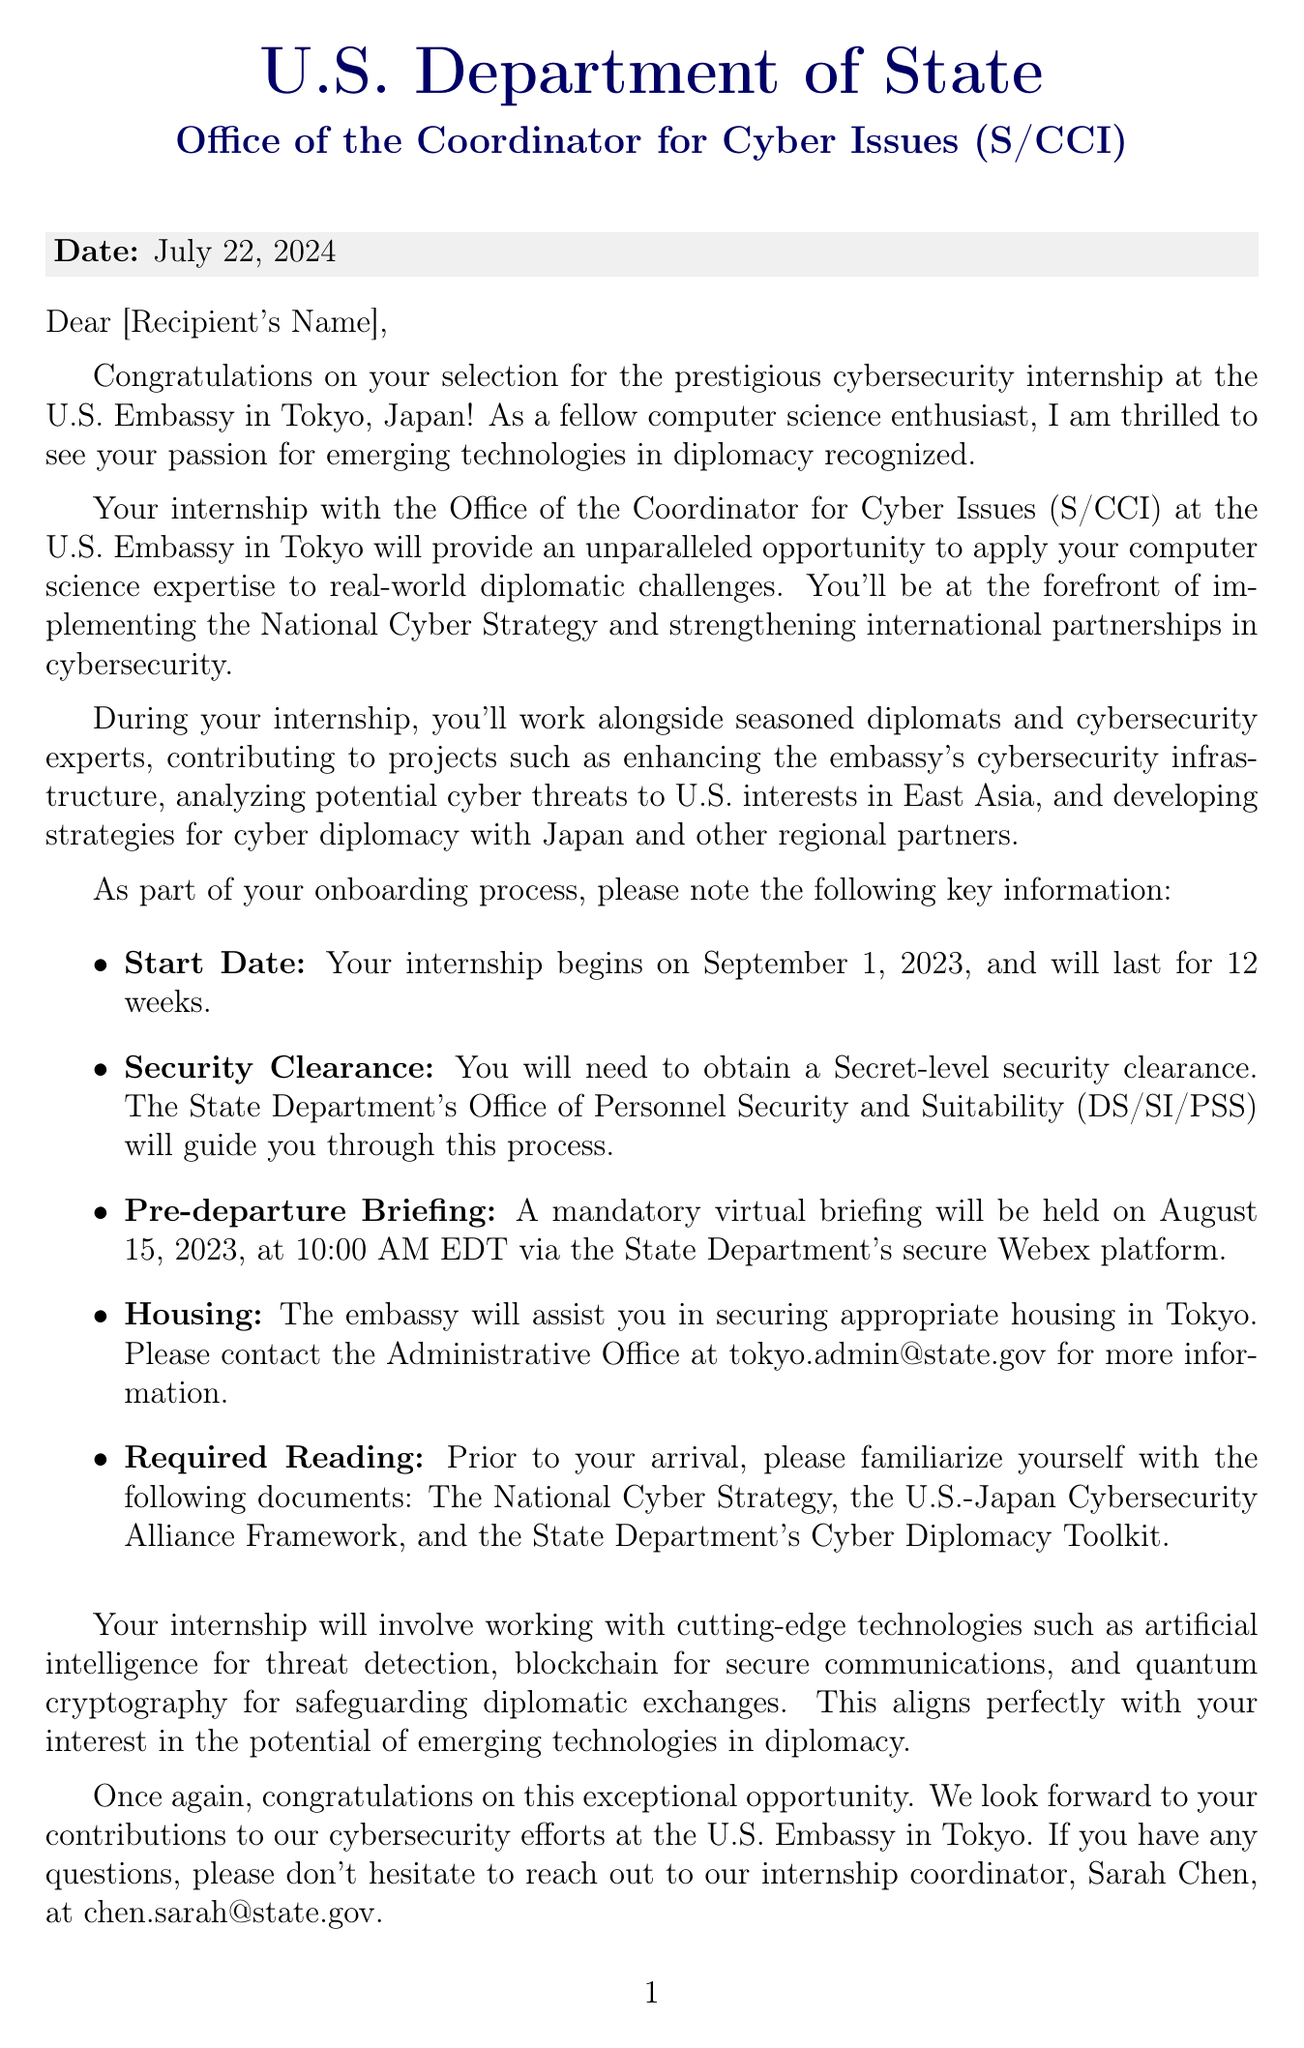What is the recipient's internship duration? The internship duration is specified in the letter as lasting for 12 weeks, starting from the start date.
Answer: 12 weeks When is the mandatory pre-departure briefing scheduled? The document provides a specific date and time for the briefing in the onboarding section.
Answer: August 15, 2023, at 10:00 AM EDT What is the title of the position of John Smith? The letter states John Smith's position in the closing section.
Answer: Director, Office of the Coordinator for Cyber Issues (S/CCI) Where should the recipient contact for housing assistance? The document lists the email contact for housing information in the onboarding section.
Answer: tokyo.admin@state.gov What is the start date of the internship? The start date is explicitly mentioned in the onboarding section of the letter.
Answer: September 1, 2023 What type of security clearance is required for the internship? The requirement for the security clearance is noted as Secret-level in the onboarding details.
Answer: Secret-level What document should the recipient read before arrival? Multiple readings are listed; the first one is mentioned in the onboarding portion of the letter.
Answer: The National Cyber Strategy What is the name of the internship coordinator? The letter specifically identifies the internship coordinator's name in the closing remarks.
Answer: Sarah Chen Which cutting-edge technology is mentioned as being related to threat detection? The document outlines specific technologies related to the internship, including one for threat detection.
Answer: Artificial intelligence 